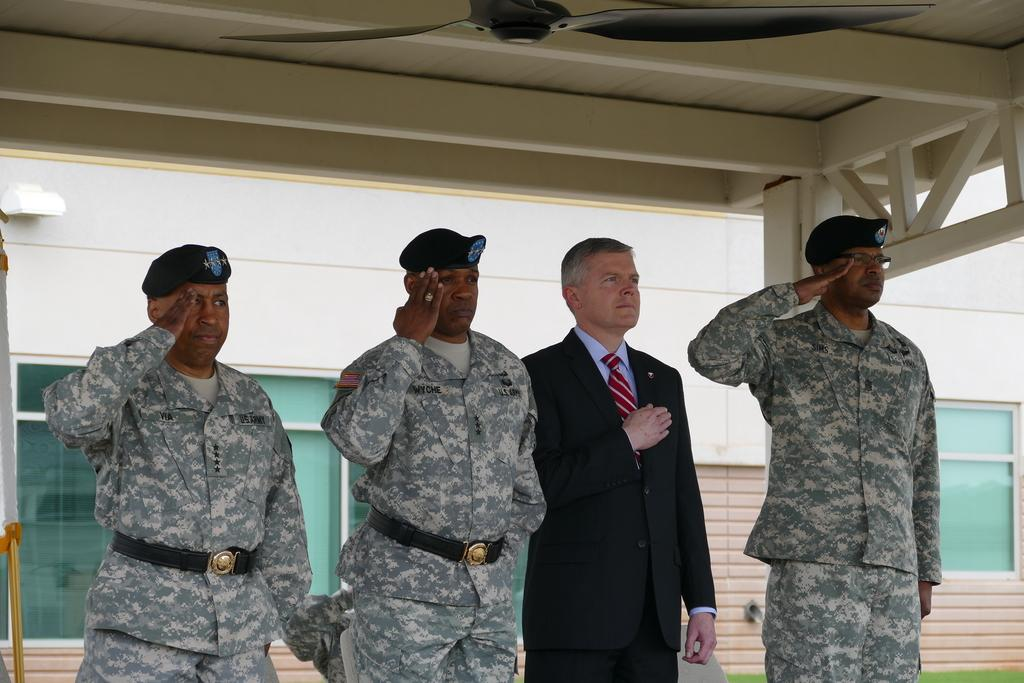How many people are in the image? There are four men in the image. What are the men wearing? Three of the men are wearing uniforms and hats, while one man is wearing a shirt, a tie, and a suit. What can be seen in the background of the image? There is a wall visible in the background of the image. Can you see a cat sleeping on the wall in the image? No, there is no cat or any indication of sleeping in the image. 